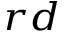<formula> <loc_0><loc_0><loc_500><loc_500>^ { r d }</formula> 